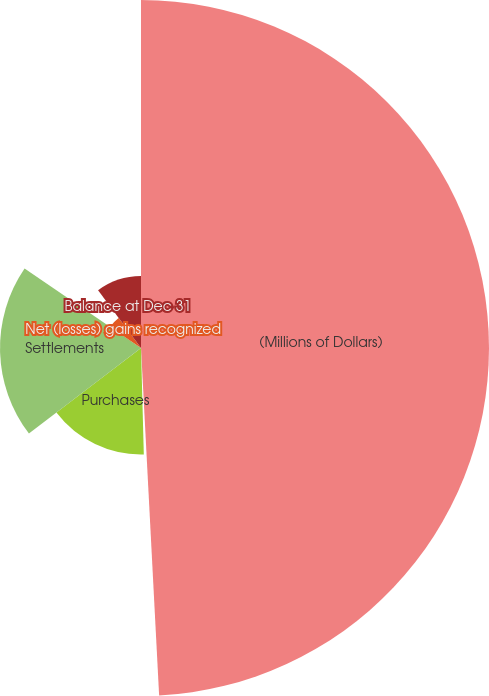<chart> <loc_0><loc_0><loc_500><loc_500><pie_chart><fcel>(Millions of Dollars)<fcel>Balance at Jan 1<fcel>Purchases<fcel>Settlements<fcel>Net (losses) gains recognized<fcel>Balance at Dec 31<nl><fcel>49.17%<fcel>0.41%<fcel>15.04%<fcel>19.92%<fcel>5.29%<fcel>10.17%<nl></chart> 